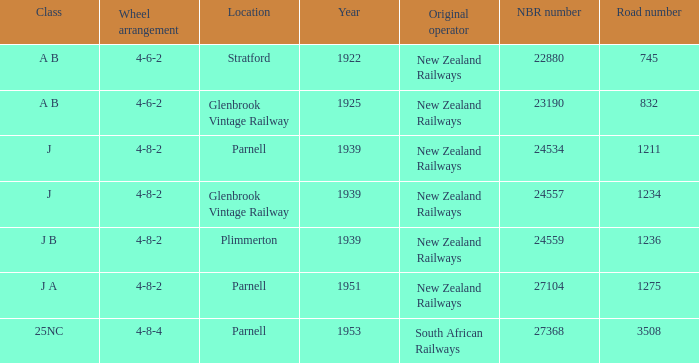How many road numbers are before 1922? 0.0. 